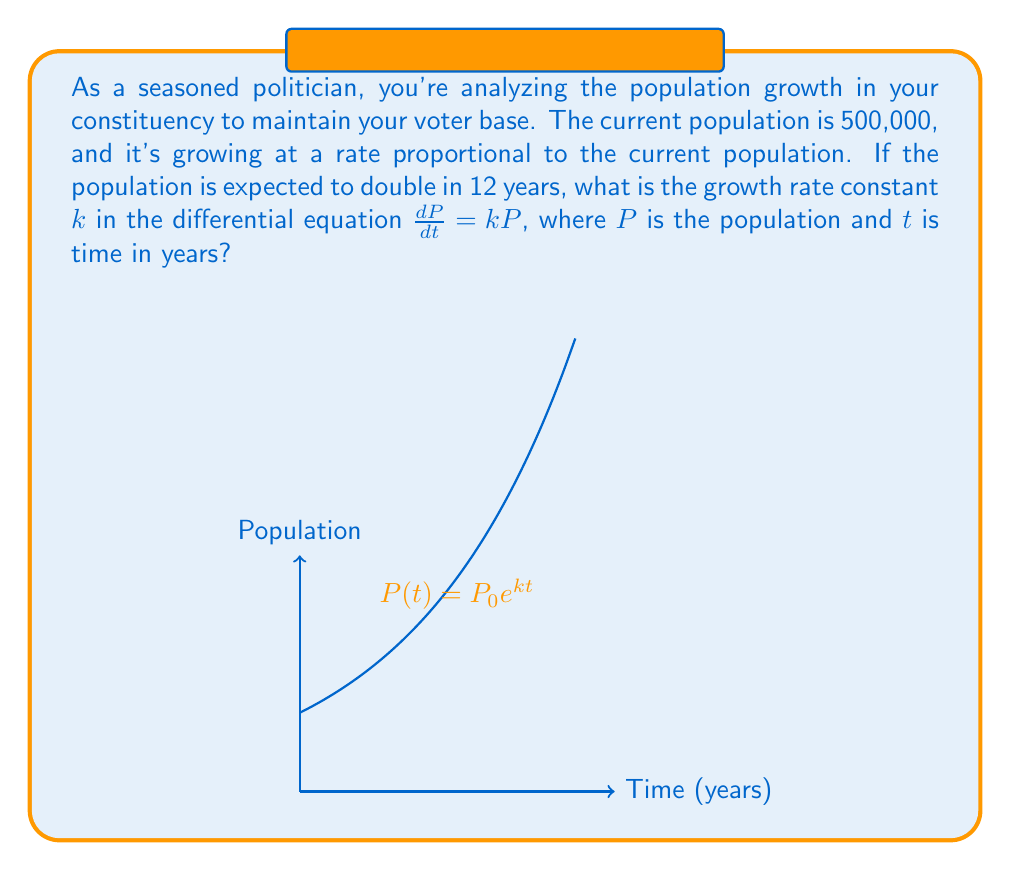What is the answer to this math problem? Let's approach this step-by-step:

1) The differential equation for exponential growth is:

   $$\frac{dP}{dt} = kP$$

2) The solution to this equation is:

   $$P(t) = P_0e^{kt}$$

   where $P_0$ is the initial population.

3) We're told that the population doubles in 12 years. This means:

   $$P(12) = 2P_0$$

4) Substituting this into our solution:

   $$2P_0 = P_0e^{12k}$$

5) Dividing both sides by $P_0$:

   $$2 = e^{12k}$$

6) Taking the natural logarithm of both sides:

   $$\ln(2) = 12k$$

7) Solving for $k$:

   $$k = \frac{\ln(2)}{12}$$

8) Calculate the value:

   $$k = \frac{0.693147...}{12} \approx 0.0577623...$$
Answer: $k \approx 0.0578$ year$^{-1}$ 